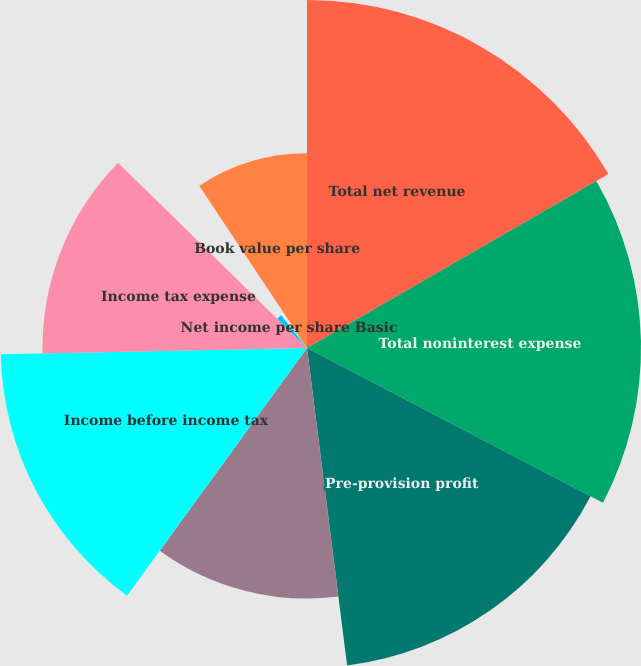Convert chart. <chart><loc_0><loc_0><loc_500><loc_500><pie_chart><fcel>Total net revenue<fcel>Total noninterest expense<fcel>Pre-provision profit<fcel>Provision for credit losses<fcel>Income before income tax<fcel>Income tax expense<fcel>Net income per share Basic<fcel>Diluted<fcel>Cash dividends declared per<fcel>Book value per share<nl><fcel>16.67%<fcel>16.0%<fcel>15.33%<fcel>12.0%<fcel>14.67%<fcel>12.67%<fcel>2.0%<fcel>1.33%<fcel>0.0%<fcel>9.33%<nl></chart> 